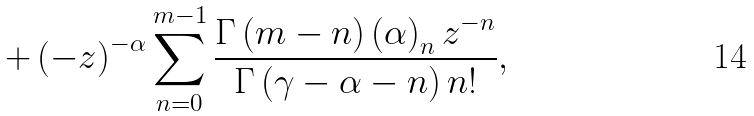Convert formula to latex. <formula><loc_0><loc_0><loc_500><loc_500>+ \left ( - z \right ) ^ { - \alpha } \sum _ { n = 0 } ^ { m - 1 } \frac { \Gamma \left ( m - n \right ) \left ( \alpha \right ) _ { n } z ^ { - n } } { \Gamma \left ( \gamma - \alpha - n \right ) n ! } ,</formula> 